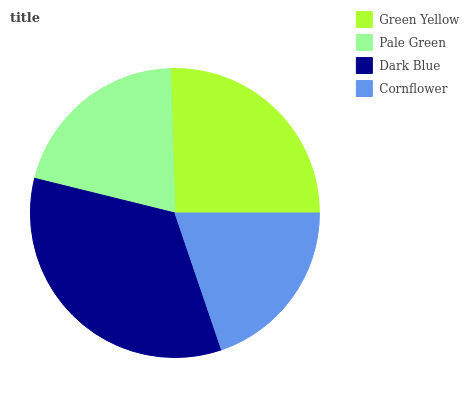Is Cornflower the minimum?
Answer yes or no. Yes. Is Dark Blue the maximum?
Answer yes or no. Yes. Is Pale Green the minimum?
Answer yes or no. No. Is Pale Green the maximum?
Answer yes or no. No. Is Green Yellow greater than Pale Green?
Answer yes or no. Yes. Is Pale Green less than Green Yellow?
Answer yes or no. Yes. Is Pale Green greater than Green Yellow?
Answer yes or no. No. Is Green Yellow less than Pale Green?
Answer yes or no. No. Is Green Yellow the high median?
Answer yes or no. Yes. Is Pale Green the low median?
Answer yes or no. Yes. Is Dark Blue the high median?
Answer yes or no. No. Is Dark Blue the low median?
Answer yes or no. No. 